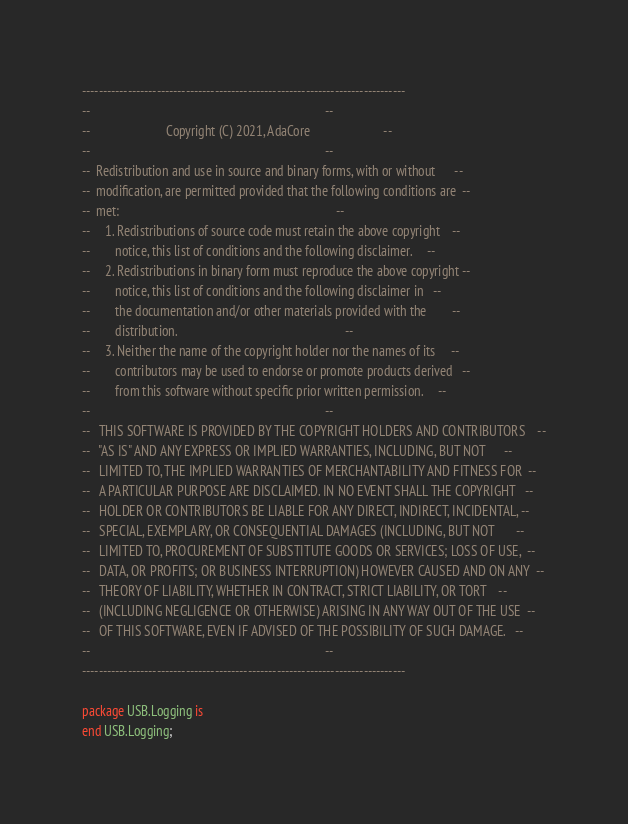Convert code to text. <code><loc_0><loc_0><loc_500><loc_500><_Ada_>------------------------------------------------------------------------------
--                                                                          --
--                        Copyright (C) 2021, AdaCore                       --
--                                                                          --
--  Redistribution and use in source and binary forms, with or without      --
--  modification, are permitted provided that the following conditions are  --
--  met:                                                                    --
--     1. Redistributions of source code must retain the above copyright    --
--        notice, this list of conditions and the following disclaimer.     --
--     2. Redistributions in binary form must reproduce the above copyright --
--        notice, this list of conditions and the following disclaimer in   --
--        the documentation and/or other materials provided with the        --
--        distribution.                                                     --
--     3. Neither the name of the copyright holder nor the names of its     --
--        contributors may be used to endorse or promote products derived   --
--        from this software without specific prior written permission.     --
--                                                                          --
--   THIS SOFTWARE IS PROVIDED BY THE COPYRIGHT HOLDERS AND CONTRIBUTORS    --
--   "AS IS" AND ANY EXPRESS OR IMPLIED WARRANTIES, INCLUDING, BUT NOT      --
--   LIMITED TO, THE IMPLIED WARRANTIES OF MERCHANTABILITY AND FITNESS FOR  --
--   A PARTICULAR PURPOSE ARE DISCLAIMED. IN NO EVENT SHALL THE COPYRIGHT   --
--   HOLDER OR CONTRIBUTORS BE LIABLE FOR ANY DIRECT, INDIRECT, INCIDENTAL, --
--   SPECIAL, EXEMPLARY, OR CONSEQUENTIAL DAMAGES (INCLUDING, BUT NOT       --
--   LIMITED TO, PROCUREMENT OF SUBSTITUTE GOODS OR SERVICES; LOSS OF USE,  --
--   DATA, OR PROFITS; OR BUSINESS INTERRUPTION) HOWEVER CAUSED AND ON ANY  --
--   THEORY OF LIABILITY, WHETHER IN CONTRACT, STRICT LIABILITY, OR TORT    --
--   (INCLUDING NEGLIGENCE OR OTHERWISE) ARISING IN ANY WAY OUT OF THE USE  --
--   OF THIS SOFTWARE, EVEN IF ADVISED OF THE POSSIBILITY OF SUCH DAMAGE.   --
--                                                                          --
------------------------------------------------------------------------------

package USB.Logging is
end USB.Logging;
</code> 